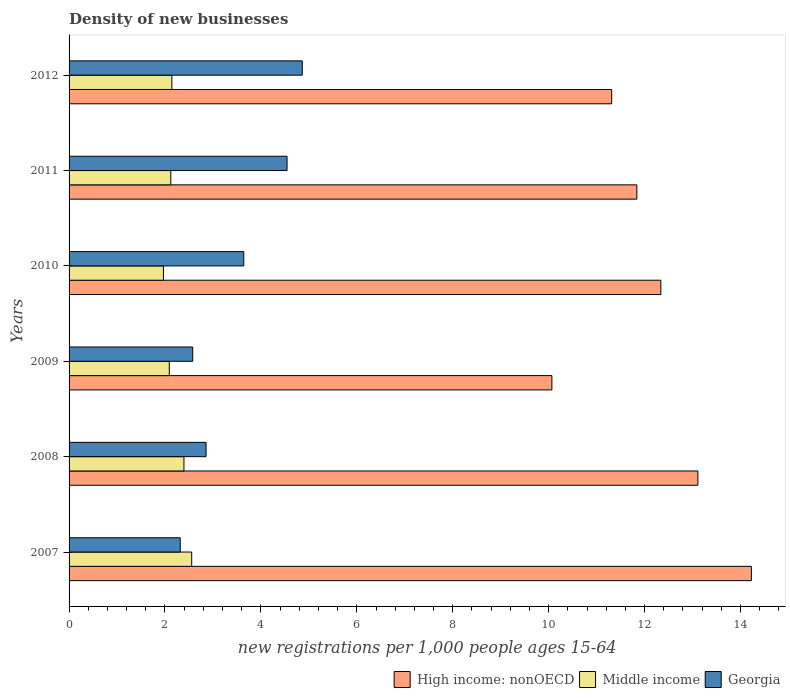How many groups of bars are there?
Your response must be concise. 6. Are the number of bars per tick equal to the number of legend labels?
Make the answer very short. Yes. Are the number of bars on each tick of the Y-axis equal?
Keep it short and to the point. Yes. How many bars are there on the 1st tick from the top?
Your response must be concise. 3. How many bars are there on the 4th tick from the bottom?
Provide a short and direct response. 3. In how many cases, is the number of bars for a given year not equal to the number of legend labels?
Ensure brevity in your answer.  0. What is the number of new registrations in High income: nonOECD in 2008?
Keep it short and to the point. 13.11. Across all years, what is the maximum number of new registrations in High income: nonOECD?
Make the answer very short. 14.23. Across all years, what is the minimum number of new registrations in Georgia?
Provide a short and direct response. 2.32. In which year was the number of new registrations in Georgia maximum?
Provide a succinct answer. 2012. In which year was the number of new registrations in High income: nonOECD minimum?
Offer a very short reply. 2009. What is the total number of new registrations in Middle income in the graph?
Your response must be concise. 13.28. What is the difference between the number of new registrations in Middle income in 2011 and that in 2012?
Your answer should be compact. -0.02. What is the difference between the number of new registrations in Middle income in 2010 and the number of new registrations in Georgia in 2007?
Offer a terse response. -0.35. What is the average number of new registrations in Middle income per year?
Offer a terse response. 2.21. In the year 2012, what is the difference between the number of new registrations in Georgia and number of new registrations in Middle income?
Provide a short and direct response. 2.72. In how many years, is the number of new registrations in Georgia greater than 5.2 ?
Offer a terse response. 0. What is the ratio of the number of new registrations in Middle income in 2011 to that in 2012?
Ensure brevity in your answer.  0.99. Is the number of new registrations in Middle income in 2009 less than that in 2010?
Keep it short and to the point. No. What is the difference between the highest and the second highest number of new registrations in High income: nonOECD?
Your answer should be compact. 1.12. What is the difference between the highest and the lowest number of new registrations in High income: nonOECD?
Ensure brevity in your answer.  4.16. Is the sum of the number of new registrations in Georgia in 2007 and 2011 greater than the maximum number of new registrations in High income: nonOECD across all years?
Make the answer very short. No. What does the 3rd bar from the bottom in 2011 represents?
Ensure brevity in your answer.  Georgia. Are all the bars in the graph horizontal?
Ensure brevity in your answer.  Yes. How many years are there in the graph?
Offer a terse response. 6. How are the legend labels stacked?
Your answer should be very brief. Horizontal. What is the title of the graph?
Offer a terse response. Density of new businesses. Does "Hungary" appear as one of the legend labels in the graph?
Make the answer very short. No. What is the label or title of the X-axis?
Make the answer very short. New registrations per 1,0 people ages 15-64. What is the new registrations per 1,000 people ages 15-64 of High income: nonOECD in 2007?
Make the answer very short. 14.23. What is the new registrations per 1,000 people ages 15-64 of Middle income in 2007?
Offer a very short reply. 2.56. What is the new registrations per 1,000 people ages 15-64 of Georgia in 2007?
Your answer should be very brief. 2.32. What is the new registrations per 1,000 people ages 15-64 in High income: nonOECD in 2008?
Your response must be concise. 13.11. What is the new registrations per 1,000 people ages 15-64 in Middle income in 2008?
Give a very brief answer. 2.4. What is the new registrations per 1,000 people ages 15-64 in Georgia in 2008?
Offer a terse response. 2.86. What is the new registrations per 1,000 people ages 15-64 of High income: nonOECD in 2009?
Your answer should be very brief. 10.07. What is the new registrations per 1,000 people ages 15-64 in Middle income in 2009?
Offer a very short reply. 2.09. What is the new registrations per 1,000 people ages 15-64 of Georgia in 2009?
Your response must be concise. 2.58. What is the new registrations per 1,000 people ages 15-64 of High income: nonOECD in 2010?
Offer a very short reply. 12.34. What is the new registrations per 1,000 people ages 15-64 of Middle income in 2010?
Keep it short and to the point. 1.97. What is the new registrations per 1,000 people ages 15-64 in Georgia in 2010?
Your response must be concise. 3.64. What is the new registrations per 1,000 people ages 15-64 in High income: nonOECD in 2011?
Keep it short and to the point. 11.84. What is the new registrations per 1,000 people ages 15-64 in Middle income in 2011?
Provide a succinct answer. 2.12. What is the new registrations per 1,000 people ages 15-64 in Georgia in 2011?
Ensure brevity in your answer.  4.55. What is the new registrations per 1,000 people ages 15-64 in High income: nonOECD in 2012?
Keep it short and to the point. 11.31. What is the new registrations per 1,000 people ages 15-64 in Middle income in 2012?
Make the answer very short. 2.14. What is the new registrations per 1,000 people ages 15-64 of Georgia in 2012?
Your answer should be very brief. 4.86. Across all years, what is the maximum new registrations per 1,000 people ages 15-64 in High income: nonOECD?
Your answer should be very brief. 14.23. Across all years, what is the maximum new registrations per 1,000 people ages 15-64 in Middle income?
Offer a very short reply. 2.56. Across all years, what is the maximum new registrations per 1,000 people ages 15-64 of Georgia?
Offer a very short reply. 4.86. Across all years, what is the minimum new registrations per 1,000 people ages 15-64 in High income: nonOECD?
Provide a short and direct response. 10.07. Across all years, what is the minimum new registrations per 1,000 people ages 15-64 of Middle income?
Your answer should be compact. 1.97. Across all years, what is the minimum new registrations per 1,000 people ages 15-64 in Georgia?
Provide a succinct answer. 2.32. What is the total new registrations per 1,000 people ages 15-64 of High income: nonOECD in the graph?
Your answer should be very brief. 72.9. What is the total new registrations per 1,000 people ages 15-64 of Middle income in the graph?
Your answer should be compact. 13.28. What is the total new registrations per 1,000 people ages 15-64 of Georgia in the graph?
Offer a terse response. 20.8. What is the difference between the new registrations per 1,000 people ages 15-64 in High income: nonOECD in 2007 and that in 2008?
Your answer should be compact. 1.12. What is the difference between the new registrations per 1,000 people ages 15-64 of Middle income in 2007 and that in 2008?
Provide a short and direct response. 0.16. What is the difference between the new registrations per 1,000 people ages 15-64 in Georgia in 2007 and that in 2008?
Your answer should be very brief. -0.54. What is the difference between the new registrations per 1,000 people ages 15-64 of High income: nonOECD in 2007 and that in 2009?
Ensure brevity in your answer.  4.16. What is the difference between the new registrations per 1,000 people ages 15-64 in Middle income in 2007 and that in 2009?
Give a very brief answer. 0.47. What is the difference between the new registrations per 1,000 people ages 15-64 in Georgia in 2007 and that in 2009?
Ensure brevity in your answer.  -0.26. What is the difference between the new registrations per 1,000 people ages 15-64 of High income: nonOECD in 2007 and that in 2010?
Your answer should be compact. 1.89. What is the difference between the new registrations per 1,000 people ages 15-64 in Middle income in 2007 and that in 2010?
Make the answer very short. 0.59. What is the difference between the new registrations per 1,000 people ages 15-64 in Georgia in 2007 and that in 2010?
Your response must be concise. -1.32. What is the difference between the new registrations per 1,000 people ages 15-64 of High income: nonOECD in 2007 and that in 2011?
Give a very brief answer. 2.39. What is the difference between the new registrations per 1,000 people ages 15-64 of Middle income in 2007 and that in 2011?
Provide a succinct answer. 0.44. What is the difference between the new registrations per 1,000 people ages 15-64 of Georgia in 2007 and that in 2011?
Offer a terse response. -2.23. What is the difference between the new registrations per 1,000 people ages 15-64 of High income: nonOECD in 2007 and that in 2012?
Ensure brevity in your answer.  2.91. What is the difference between the new registrations per 1,000 people ages 15-64 in Middle income in 2007 and that in 2012?
Provide a short and direct response. 0.41. What is the difference between the new registrations per 1,000 people ages 15-64 of Georgia in 2007 and that in 2012?
Ensure brevity in your answer.  -2.54. What is the difference between the new registrations per 1,000 people ages 15-64 in High income: nonOECD in 2008 and that in 2009?
Provide a short and direct response. 3.04. What is the difference between the new registrations per 1,000 people ages 15-64 in Middle income in 2008 and that in 2009?
Your answer should be very brief. 0.3. What is the difference between the new registrations per 1,000 people ages 15-64 of Georgia in 2008 and that in 2009?
Keep it short and to the point. 0.28. What is the difference between the new registrations per 1,000 people ages 15-64 of High income: nonOECD in 2008 and that in 2010?
Your response must be concise. 0.77. What is the difference between the new registrations per 1,000 people ages 15-64 of Middle income in 2008 and that in 2010?
Offer a very short reply. 0.43. What is the difference between the new registrations per 1,000 people ages 15-64 of Georgia in 2008 and that in 2010?
Your answer should be very brief. -0.79. What is the difference between the new registrations per 1,000 people ages 15-64 of High income: nonOECD in 2008 and that in 2011?
Give a very brief answer. 1.27. What is the difference between the new registrations per 1,000 people ages 15-64 of Middle income in 2008 and that in 2011?
Offer a terse response. 0.27. What is the difference between the new registrations per 1,000 people ages 15-64 in Georgia in 2008 and that in 2011?
Make the answer very short. -1.69. What is the difference between the new registrations per 1,000 people ages 15-64 of High income: nonOECD in 2008 and that in 2012?
Give a very brief answer. 1.8. What is the difference between the new registrations per 1,000 people ages 15-64 in Middle income in 2008 and that in 2012?
Provide a succinct answer. 0.25. What is the difference between the new registrations per 1,000 people ages 15-64 in Georgia in 2008 and that in 2012?
Keep it short and to the point. -2.01. What is the difference between the new registrations per 1,000 people ages 15-64 of High income: nonOECD in 2009 and that in 2010?
Provide a short and direct response. -2.27. What is the difference between the new registrations per 1,000 people ages 15-64 of Middle income in 2009 and that in 2010?
Your answer should be very brief. 0.12. What is the difference between the new registrations per 1,000 people ages 15-64 of Georgia in 2009 and that in 2010?
Your response must be concise. -1.06. What is the difference between the new registrations per 1,000 people ages 15-64 of High income: nonOECD in 2009 and that in 2011?
Provide a short and direct response. -1.77. What is the difference between the new registrations per 1,000 people ages 15-64 in Middle income in 2009 and that in 2011?
Your response must be concise. -0.03. What is the difference between the new registrations per 1,000 people ages 15-64 in Georgia in 2009 and that in 2011?
Offer a very short reply. -1.97. What is the difference between the new registrations per 1,000 people ages 15-64 in High income: nonOECD in 2009 and that in 2012?
Your response must be concise. -1.25. What is the difference between the new registrations per 1,000 people ages 15-64 in Middle income in 2009 and that in 2012?
Make the answer very short. -0.05. What is the difference between the new registrations per 1,000 people ages 15-64 of Georgia in 2009 and that in 2012?
Offer a very short reply. -2.28. What is the difference between the new registrations per 1,000 people ages 15-64 of High income: nonOECD in 2010 and that in 2011?
Offer a very short reply. 0.5. What is the difference between the new registrations per 1,000 people ages 15-64 in Middle income in 2010 and that in 2011?
Give a very brief answer. -0.15. What is the difference between the new registrations per 1,000 people ages 15-64 in Georgia in 2010 and that in 2011?
Offer a very short reply. -0.9. What is the difference between the new registrations per 1,000 people ages 15-64 of High income: nonOECD in 2010 and that in 2012?
Give a very brief answer. 1.02. What is the difference between the new registrations per 1,000 people ages 15-64 of Middle income in 2010 and that in 2012?
Offer a very short reply. -0.18. What is the difference between the new registrations per 1,000 people ages 15-64 in Georgia in 2010 and that in 2012?
Make the answer very short. -1.22. What is the difference between the new registrations per 1,000 people ages 15-64 of High income: nonOECD in 2011 and that in 2012?
Offer a very short reply. 0.52. What is the difference between the new registrations per 1,000 people ages 15-64 of Middle income in 2011 and that in 2012?
Offer a very short reply. -0.02. What is the difference between the new registrations per 1,000 people ages 15-64 in Georgia in 2011 and that in 2012?
Give a very brief answer. -0.32. What is the difference between the new registrations per 1,000 people ages 15-64 of High income: nonOECD in 2007 and the new registrations per 1,000 people ages 15-64 of Middle income in 2008?
Your response must be concise. 11.83. What is the difference between the new registrations per 1,000 people ages 15-64 in High income: nonOECD in 2007 and the new registrations per 1,000 people ages 15-64 in Georgia in 2008?
Provide a succinct answer. 11.37. What is the difference between the new registrations per 1,000 people ages 15-64 of Middle income in 2007 and the new registrations per 1,000 people ages 15-64 of Georgia in 2008?
Give a very brief answer. -0.3. What is the difference between the new registrations per 1,000 people ages 15-64 in High income: nonOECD in 2007 and the new registrations per 1,000 people ages 15-64 in Middle income in 2009?
Offer a terse response. 12.14. What is the difference between the new registrations per 1,000 people ages 15-64 in High income: nonOECD in 2007 and the new registrations per 1,000 people ages 15-64 in Georgia in 2009?
Give a very brief answer. 11.65. What is the difference between the new registrations per 1,000 people ages 15-64 of Middle income in 2007 and the new registrations per 1,000 people ages 15-64 of Georgia in 2009?
Ensure brevity in your answer.  -0.02. What is the difference between the new registrations per 1,000 people ages 15-64 in High income: nonOECD in 2007 and the new registrations per 1,000 people ages 15-64 in Middle income in 2010?
Ensure brevity in your answer.  12.26. What is the difference between the new registrations per 1,000 people ages 15-64 of High income: nonOECD in 2007 and the new registrations per 1,000 people ages 15-64 of Georgia in 2010?
Offer a terse response. 10.59. What is the difference between the new registrations per 1,000 people ages 15-64 in Middle income in 2007 and the new registrations per 1,000 people ages 15-64 in Georgia in 2010?
Keep it short and to the point. -1.08. What is the difference between the new registrations per 1,000 people ages 15-64 in High income: nonOECD in 2007 and the new registrations per 1,000 people ages 15-64 in Middle income in 2011?
Make the answer very short. 12.11. What is the difference between the new registrations per 1,000 people ages 15-64 in High income: nonOECD in 2007 and the new registrations per 1,000 people ages 15-64 in Georgia in 2011?
Your response must be concise. 9.68. What is the difference between the new registrations per 1,000 people ages 15-64 in Middle income in 2007 and the new registrations per 1,000 people ages 15-64 in Georgia in 2011?
Provide a succinct answer. -1.99. What is the difference between the new registrations per 1,000 people ages 15-64 in High income: nonOECD in 2007 and the new registrations per 1,000 people ages 15-64 in Middle income in 2012?
Your answer should be very brief. 12.08. What is the difference between the new registrations per 1,000 people ages 15-64 of High income: nonOECD in 2007 and the new registrations per 1,000 people ages 15-64 of Georgia in 2012?
Your answer should be very brief. 9.37. What is the difference between the new registrations per 1,000 people ages 15-64 in Middle income in 2007 and the new registrations per 1,000 people ages 15-64 in Georgia in 2012?
Give a very brief answer. -2.31. What is the difference between the new registrations per 1,000 people ages 15-64 in High income: nonOECD in 2008 and the new registrations per 1,000 people ages 15-64 in Middle income in 2009?
Make the answer very short. 11.02. What is the difference between the new registrations per 1,000 people ages 15-64 in High income: nonOECD in 2008 and the new registrations per 1,000 people ages 15-64 in Georgia in 2009?
Offer a very short reply. 10.53. What is the difference between the new registrations per 1,000 people ages 15-64 of Middle income in 2008 and the new registrations per 1,000 people ages 15-64 of Georgia in 2009?
Keep it short and to the point. -0.18. What is the difference between the new registrations per 1,000 people ages 15-64 of High income: nonOECD in 2008 and the new registrations per 1,000 people ages 15-64 of Middle income in 2010?
Offer a very short reply. 11.14. What is the difference between the new registrations per 1,000 people ages 15-64 of High income: nonOECD in 2008 and the new registrations per 1,000 people ages 15-64 of Georgia in 2010?
Offer a very short reply. 9.47. What is the difference between the new registrations per 1,000 people ages 15-64 of Middle income in 2008 and the new registrations per 1,000 people ages 15-64 of Georgia in 2010?
Your answer should be very brief. -1.25. What is the difference between the new registrations per 1,000 people ages 15-64 of High income: nonOECD in 2008 and the new registrations per 1,000 people ages 15-64 of Middle income in 2011?
Your answer should be very brief. 10.99. What is the difference between the new registrations per 1,000 people ages 15-64 in High income: nonOECD in 2008 and the new registrations per 1,000 people ages 15-64 in Georgia in 2011?
Ensure brevity in your answer.  8.57. What is the difference between the new registrations per 1,000 people ages 15-64 of Middle income in 2008 and the new registrations per 1,000 people ages 15-64 of Georgia in 2011?
Your answer should be compact. -2.15. What is the difference between the new registrations per 1,000 people ages 15-64 in High income: nonOECD in 2008 and the new registrations per 1,000 people ages 15-64 in Middle income in 2012?
Give a very brief answer. 10.97. What is the difference between the new registrations per 1,000 people ages 15-64 in High income: nonOECD in 2008 and the new registrations per 1,000 people ages 15-64 in Georgia in 2012?
Your answer should be very brief. 8.25. What is the difference between the new registrations per 1,000 people ages 15-64 of Middle income in 2008 and the new registrations per 1,000 people ages 15-64 of Georgia in 2012?
Provide a short and direct response. -2.47. What is the difference between the new registrations per 1,000 people ages 15-64 of High income: nonOECD in 2009 and the new registrations per 1,000 people ages 15-64 of Middle income in 2010?
Provide a succinct answer. 8.1. What is the difference between the new registrations per 1,000 people ages 15-64 of High income: nonOECD in 2009 and the new registrations per 1,000 people ages 15-64 of Georgia in 2010?
Provide a short and direct response. 6.43. What is the difference between the new registrations per 1,000 people ages 15-64 in Middle income in 2009 and the new registrations per 1,000 people ages 15-64 in Georgia in 2010?
Keep it short and to the point. -1.55. What is the difference between the new registrations per 1,000 people ages 15-64 of High income: nonOECD in 2009 and the new registrations per 1,000 people ages 15-64 of Middle income in 2011?
Provide a short and direct response. 7.95. What is the difference between the new registrations per 1,000 people ages 15-64 of High income: nonOECD in 2009 and the new registrations per 1,000 people ages 15-64 of Georgia in 2011?
Give a very brief answer. 5.52. What is the difference between the new registrations per 1,000 people ages 15-64 of Middle income in 2009 and the new registrations per 1,000 people ages 15-64 of Georgia in 2011?
Offer a terse response. -2.45. What is the difference between the new registrations per 1,000 people ages 15-64 in High income: nonOECD in 2009 and the new registrations per 1,000 people ages 15-64 in Middle income in 2012?
Your answer should be very brief. 7.92. What is the difference between the new registrations per 1,000 people ages 15-64 of High income: nonOECD in 2009 and the new registrations per 1,000 people ages 15-64 of Georgia in 2012?
Provide a succinct answer. 5.21. What is the difference between the new registrations per 1,000 people ages 15-64 of Middle income in 2009 and the new registrations per 1,000 people ages 15-64 of Georgia in 2012?
Your response must be concise. -2.77. What is the difference between the new registrations per 1,000 people ages 15-64 of High income: nonOECD in 2010 and the new registrations per 1,000 people ages 15-64 of Middle income in 2011?
Your answer should be very brief. 10.22. What is the difference between the new registrations per 1,000 people ages 15-64 in High income: nonOECD in 2010 and the new registrations per 1,000 people ages 15-64 in Georgia in 2011?
Your response must be concise. 7.79. What is the difference between the new registrations per 1,000 people ages 15-64 of Middle income in 2010 and the new registrations per 1,000 people ages 15-64 of Georgia in 2011?
Your answer should be very brief. -2.58. What is the difference between the new registrations per 1,000 people ages 15-64 in High income: nonOECD in 2010 and the new registrations per 1,000 people ages 15-64 in Middle income in 2012?
Provide a succinct answer. 10.2. What is the difference between the new registrations per 1,000 people ages 15-64 of High income: nonOECD in 2010 and the new registrations per 1,000 people ages 15-64 of Georgia in 2012?
Your answer should be very brief. 7.48. What is the difference between the new registrations per 1,000 people ages 15-64 in Middle income in 2010 and the new registrations per 1,000 people ages 15-64 in Georgia in 2012?
Offer a terse response. -2.89. What is the difference between the new registrations per 1,000 people ages 15-64 of High income: nonOECD in 2011 and the new registrations per 1,000 people ages 15-64 of Middle income in 2012?
Offer a very short reply. 9.7. What is the difference between the new registrations per 1,000 people ages 15-64 in High income: nonOECD in 2011 and the new registrations per 1,000 people ages 15-64 in Georgia in 2012?
Your response must be concise. 6.98. What is the difference between the new registrations per 1,000 people ages 15-64 of Middle income in 2011 and the new registrations per 1,000 people ages 15-64 of Georgia in 2012?
Your answer should be compact. -2.74. What is the average new registrations per 1,000 people ages 15-64 in High income: nonOECD per year?
Keep it short and to the point. 12.15. What is the average new registrations per 1,000 people ages 15-64 in Middle income per year?
Ensure brevity in your answer.  2.21. What is the average new registrations per 1,000 people ages 15-64 in Georgia per year?
Provide a succinct answer. 3.47. In the year 2007, what is the difference between the new registrations per 1,000 people ages 15-64 in High income: nonOECD and new registrations per 1,000 people ages 15-64 in Middle income?
Your response must be concise. 11.67. In the year 2007, what is the difference between the new registrations per 1,000 people ages 15-64 of High income: nonOECD and new registrations per 1,000 people ages 15-64 of Georgia?
Provide a succinct answer. 11.91. In the year 2007, what is the difference between the new registrations per 1,000 people ages 15-64 of Middle income and new registrations per 1,000 people ages 15-64 of Georgia?
Your answer should be compact. 0.24. In the year 2008, what is the difference between the new registrations per 1,000 people ages 15-64 of High income: nonOECD and new registrations per 1,000 people ages 15-64 of Middle income?
Keep it short and to the point. 10.72. In the year 2008, what is the difference between the new registrations per 1,000 people ages 15-64 of High income: nonOECD and new registrations per 1,000 people ages 15-64 of Georgia?
Give a very brief answer. 10.26. In the year 2008, what is the difference between the new registrations per 1,000 people ages 15-64 in Middle income and new registrations per 1,000 people ages 15-64 in Georgia?
Your answer should be very brief. -0.46. In the year 2009, what is the difference between the new registrations per 1,000 people ages 15-64 of High income: nonOECD and new registrations per 1,000 people ages 15-64 of Middle income?
Give a very brief answer. 7.98. In the year 2009, what is the difference between the new registrations per 1,000 people ages 15-64 in High income: nonOECD and new registrations per 1,000 people ages 15-64 in Georgia?
Keep it short and to the point. 7.49. In the year 2009, what is the difference between the new registrations per 1,000 people ages 15-64 in Middle income and new registrations per 1,000 people ages 15-64 in Georgia?
Provide a short and direct response. -0.49. In the year 2010, what is the difference between the new registrations per 1,000 people ages 15-64 of High income: nonOECD and new registrations per 1,000 people ages 15-64 of Middle income?
Your answer should be compact. 10.37. In the year 2010, what is the difference between the new registrations per 1,000 people ages 15-64 of High income: nonOECD and new registrations per 1,000 people ages 15-64 of Georgia?
Your answer should be very brief. 8.7. In the year 2010, what is the difference between the new registrations per 1,000 people ages 15-64 in Middle income and new registrations per 1,000 people ages 15-64 in Georgia?
Your response must be concise. -1.67. In the year 2011, what is the difference between the new registrations per 1,000 people ages 15-64 in High income: nonOECD and new registrations per 1,000 people ages 15-64 in Middle income?
Offer a terse response. 9.72. In the year 2011, what is the difference between the new registrations per 1,000 people ages 15-64 of High income: nonOECD and new registrations per 1,000 people ages 15-64 of Georgia?
Provide a succinct answer. 7.29. In the year 2011, what is the difference between the new registrations per 1,000 people ages 15-64 in Middle income and new registrations per 1,000 people ages 15-64 in Georgia?
Give a very brief answer. -2.42. In the year 2012, what is the difference between the new registrations per 1,000 people ages 15-64 in High income: nonOECD and new registrations per 1,000 people ages 15-64 in Middle income?
Make the answer very short. 9.17. In the year 2012, what is the difference between the new registrations per 1,000 people ages 15-64 of High income: nonOECD and new registrations per 1,000 people ages 15-64 of Georgia?
Provide a succinct answer. 6.45. In the year 2012, what is the difference between the new registrations per 1,000 people ages 15-64 of Middle income and new registrations per 1,000 people ages 15-64 of Georgia?
Ensure brevity in your answer.  -2.72. What is the ratio of the new registrations per 1,000 people ages 15-64 in High income: nonOECD in 2007 to that in 2008?
Make the answer very short. 1.09. What is the ratio of the new registrations per 1,000 people ages 15-64 of Middle income in 2007 to that in 2008?
Your answer should be very brief. 1.07. What is the ratio of the new registrations per 1,000 people ages 15-64 of Georgia in 2007 to that in 2008?
Offer a terse response. 0.81. What is the ratio of the new registrations per 1,000 people ages 15-64 in High income: nonOECD in 2007 to that in 2009?
Make the answer very short. 1.41. What is the ratio of the new registrations per 1,000 people ages 15-64 of Middle income in 2007 to that in 2009?
Ensure brevity in your answer.  1.22. What is the ratio of the new registrations per 1,000 people ages 15-64 of Georgia in 2007 to that in 2009?
Provide a succinct answer. 0.9. What is the ratio of the new registrations per 1,000 people ages 15-64 in High income: nonOECD in 2007 to that in 2010?
Give a very brief answer. 1.15. What is the ratio of the new registrations per 1,000 people ages 15-64 in Middle income in 2007 to that in 2010?
Offer a terse response. 1.3. What is the ratio of the new registrations per 1,000 people ages 15-64 in Georgia in 2007 to that in 2010?
Make the answer very short. 0.64. What is the ratio of the new registrations per 1,000 people ages 15-64 of High income: nonOECD in 2007 to that in 2011?
Your response must be concise. 1.2. What is the ratio of the new registrations per 1,000 people ages 15-64 in Middle income in 2007 to that in 2011?
Give a very brief answer. 1.21. What is the ratio of the new registrations per 1,000 people ages 15-64 of Georgia in 2007 to that in 2011?
Ensure brevity in your answer.  0.51. What is the ratio of the new registrations per 1,000 people ages 15-64 of High income: nonOECD in 2007 to that in 2012?
Give a very brief answer. 1.26. What is the ratio of the new registrations per 1,000 people ages 15-64 of Middle income in 2007 to that in 2012?
Ensure brevity in your answer.  1.19. What is the ratio of the new registrations per 1,000 people ages 15-64 of Georgia in 2007 to that in 2012?
Ensure brevity in your answer.  0.48. What is the ratio of the new registrations per 1,000 people ages 15-64 in High income: nonOECD in 2008 to that in 2009?
Provide a succinct answer. 1.3. What is the ratio of the new registrations per 1,000 people ages 15-64 in Middle income in 2008 to that in 2009?
Your answer should be very brief. 1.15. What is the ratio of the new registrations per 1,000 people ages 15-64 of Georgia in 2008 to that in 2009?
Offer a very short reply. 1.11. What is the ratio of the new registrations per 1,000 people ages 15-64 in High income: nonOECD in 2008 to that in 2010?
Your response must be concise. 1.06. What is the ratio of the new registrations per 1,000 people ages 15-64 in Middle income in 2008 to that in 2010?
Your response must be concise. 1.22. What is the ratio of the new registrations per 1,000 people ages 15-64 in Georgia in 2008 to that in 2010?
Provide a short and direct response. 0.78. What is the ratio of the new registrations per 1,000 people ages 15-64 of High income: nonOECD in 2008 to that in 2011?
Make the answer very short. 1.11. What is the ratio of the new registrations per 1,000 people ages 15-64 in Middle income in 2008 to that in 2011?
Your answer should be very brief. 1.13. What is the ratio of the new registrations per 1,000 people ages 15-64 in Georgia in 2008 to that in 2011?
Make the answer very short. 0.63. What is the ratio of the new registrations per 1,000 people ages 15-64 in High income: nonOECD in 2008 to that in 2012?
Give a very brief answer. 1.16. What is the ratio of the new registrations per 1,000 people ages 15-64 in Middle income in 2008 to that in 2012?
Give a very brief answer. 1.12. What is the ratio of the new registrations per 1,000 people ages 15-64 of Georgia in 2008 to that in 2012?
Make the answer very short. 0.59. What is the ratio of the new registrations per 1,000 people ages 15-64 of High income: nonOECD in 2009 to that in 2010?
Your answer should be very brief. 0.82. What is the ratio of the new registrations per 1,000 people ages 15-64 in Middle income in 2009 to that in 2010?
Make the answer very short. 1.06. What is the ratio of the new registrations per 1,000 people ages 15-64 of Georgia in 2009 to that in 2010?
Keep it short and to the point. 0.71. What is the ratio of the new registrations per 1,000 people ages 15-64 in High income: nonOECD in 2009 to that in 2011?
Offer a very short reply. 0.85. What is the ratio of the new registrations per 1,000 people ages 15-64 in Middle income in 2009 to that in 2011?
Offer a very short reply. 0.99. What is the ratio of the new registrations per 1,000 people ages 15-64 in Georgia in 2009 to that in 2011?
Provide a short and direct response. 0.57. What is the ratio of the new registrations per 1,000 people ages 15-64 of High income: nonOECD in 2009 to that in 2012?
Your response must be concise. 0.89. What is the ratio of the new registrations per 1,000 people ages 15-64 in Middle income in 2009 to that in 2012?
Offer a terse response. 0.98. What is the ratio of the new registrations per 1,000 people ages 15-64 of Georgia in 2009 to that in 2012?
Keep it short and to the point. 0.53. What is the ratio of the new registrations per 1,000 people ages 15-64 in High income: nonOECD in 2010 to that in 2011?
Your response must be concise. 1.04. What is the ratio of the new registrations per 1,000 people ages 15-64 of Middle income in 2010 to that in 2011?
Provide a succinct answer. 0.93. What is the ratio of the new registrations per 1,000 people ages 15-64 in Georgia in 2010 to that in 2011?
Your response must be concise. 0.8. What is the ratio of the new registrations per 1,000 people ages 15-64 in High income: nonOECD in 2010 to that in 2012?
Give a very brief answer. 1.09. What is the ratio of the new registrations per 1,000 people ages 15-64 in Middle income in 2010 to that in 2012?
Give a very brief answer. 0.92. What is the ratio of the new registrations per 1,000 people ages 15-64 of Georgia in 2010 to that in 2012?
Ensure brevity in your answer.  0.75. What is the ratio of the new registrations per 1,000 people ages 15-64 in High income: nonOECD in 2011 to that in 2012?
Your answer should be compact. 1.05. What is the ratio of the new registrations per 1,000 people ages 15-64 of Middle income in 2011 to that in 2012?
Provide a succinct answer. 0.99. What is the ratio of the new registrations per 1,000 people ages 15-64 in Georgia in 2011 to that in 2012?
Provide a succinct answer. 0.93. What is the difference between the highest and the second highest new registrations per 1,000 people ages 15-64 of High income: nonOECD?
Offer a very short reply. 1.12. What is the difference between the highest and the second highest new registrations per 1,000 people ages 15-64 of Middle income?
Your answer should be very brief. 0.16. What is the difference between the highest and the second highest new registrations per 1,000 people ages 15-64 of Georgia?
Provide a succinct answer. 0.32. What is the difference between the highest and the lowest new registrations per 1,000 people ages 15-64 in High income: nonOECD?
Offer a terse response. 4.16. What is the difference between the highest and the lowest new registrations per 1,000 people ages 15-64 in Middle income?
Make the answer very short. 0.59. What is the difference between the highest and the lowest new registrations per 1,000 people ages 15-64 of Georgia?
Your answer should be very brief. 2.54. 